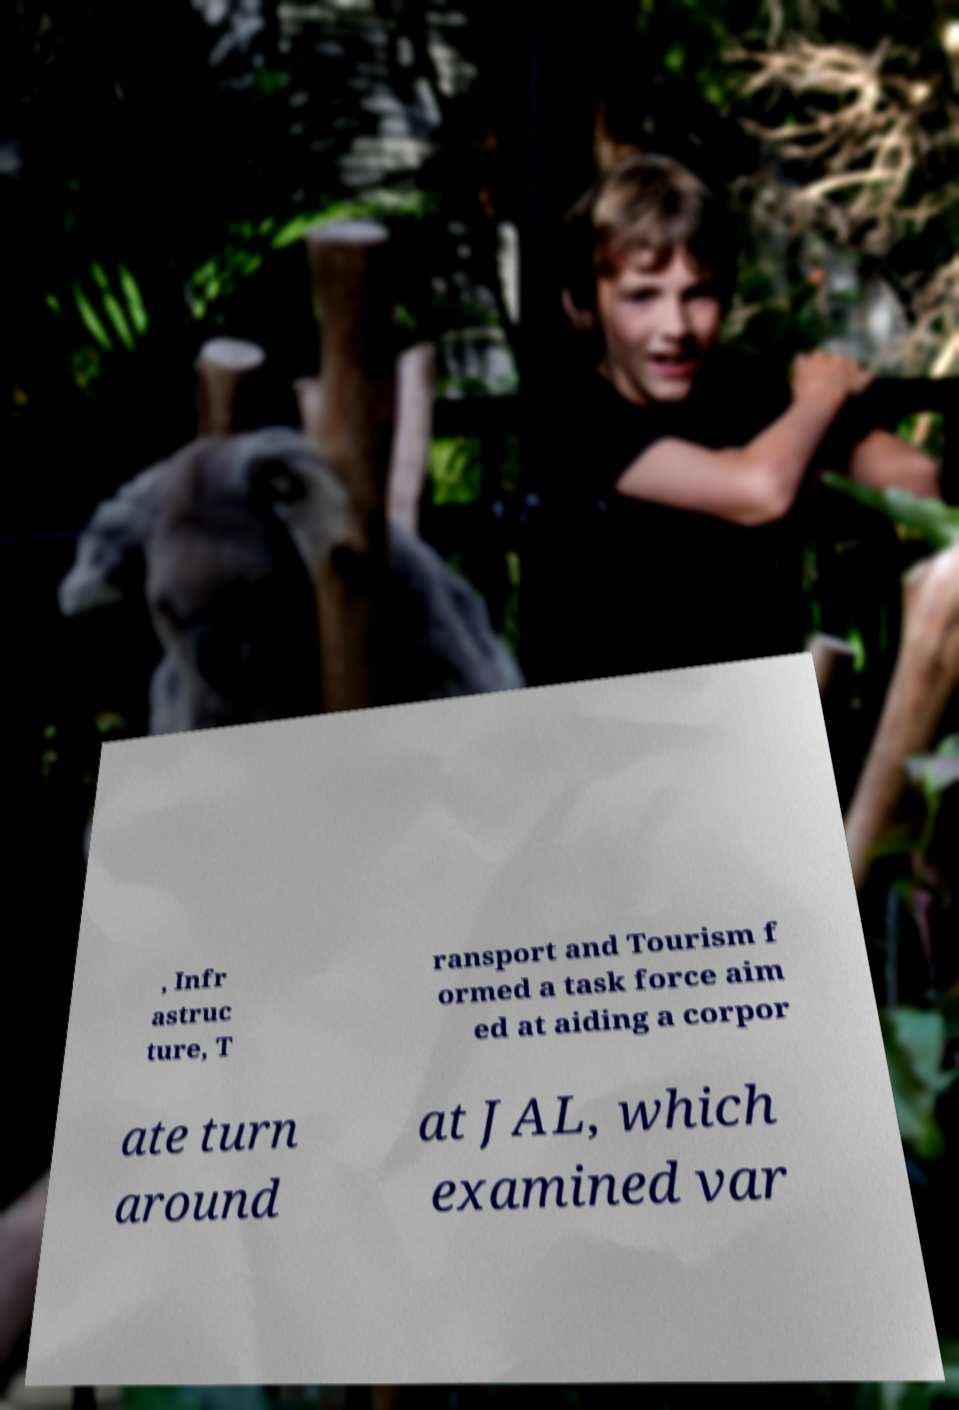I need the written content from this picture converted into text. Can you do that? , Infr astruc ture, T ransport and Tourism f ormed a task force aim ed at aiding a corpor ate turn around at JAL, which examined var 